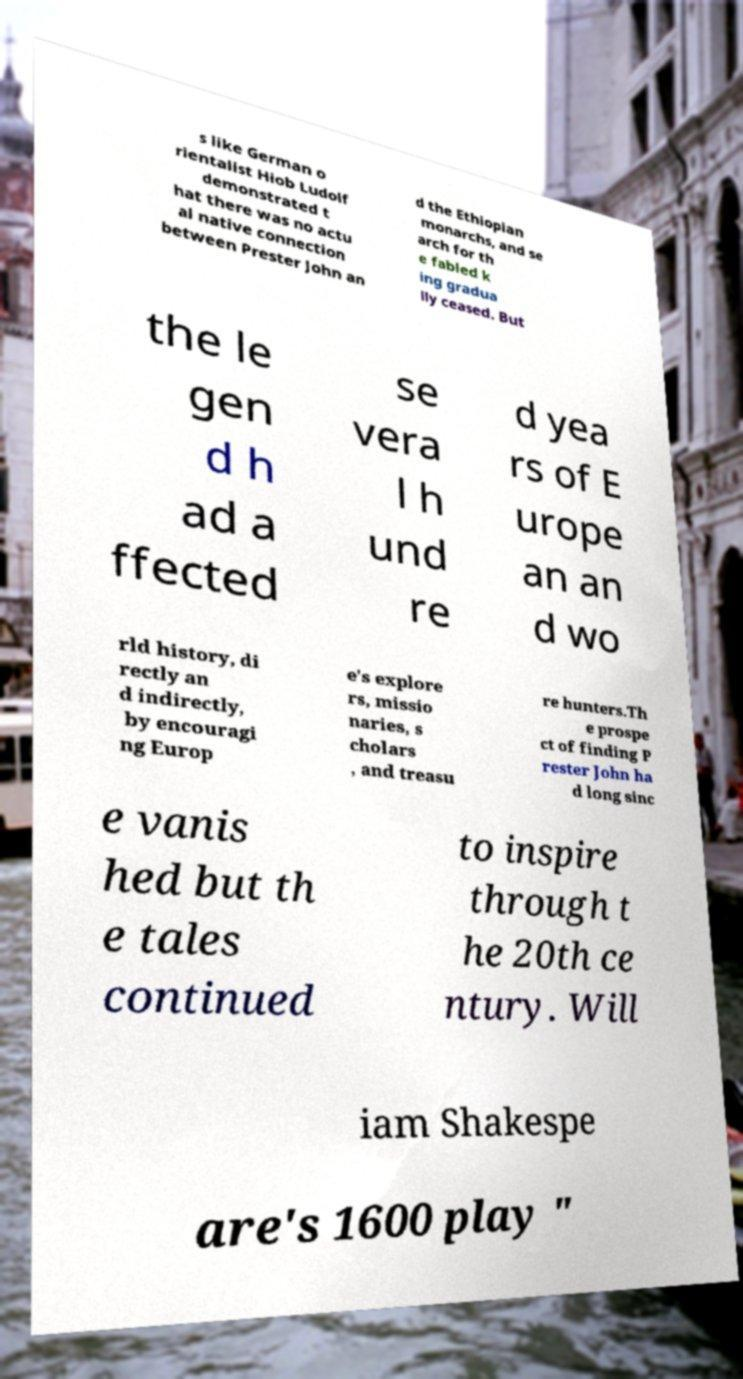Please identify and transcribe the text found in this image. s like German o rientalist Hiob Ludolf demonstrated t hat there was no actu al native connection between Prester John an d the Ethiopian monarchs, and se arch for th e fabled k ing gradua lly ceased. But the le gen d h ad a ffected se vera l h und re d yea rs of E urope an an d wo rld history, di rectly an d indirectly, by encouragi ng Europ e's explore rs, missio naries, s cholars , and treasu re hunters.Th e prospe ct of finding P rester John ha d long sinc e vanis hed but th e tales continued to inspire through t he 20th ce ntury. Will iam Shakespe are's 1600 play " 